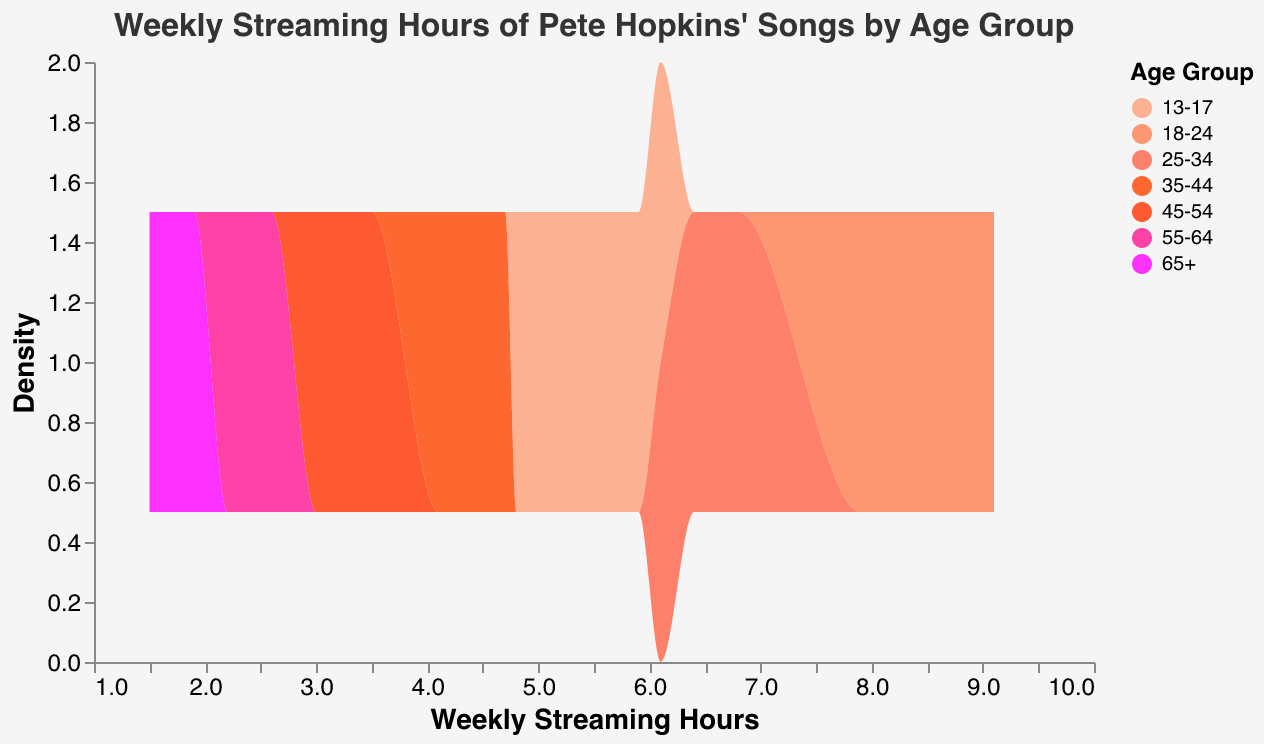What's the title of the density plot? The title of the plot is located at the top. It reads "Weekly Streaming Hours of Pete Hopkins' Songs by Age Group".
Answer: Weekly Streaming Hours of Pete Hopkins' Songs by Age Group What are the age groups displayed in the legend? The age groups are shown in the color legend on the right side of the plot. They include 13-17, 18-24, 25-34, 35-44, 45-54, 55-64, and 65+.
Answer: 13-17, 18-24, 25-34, 35-44, 45-54, 55-64, 65+ Which age group has the highest density peak? The density peak is the highest point on the density curve, indicating the highest concentration of data points. The age group 18-24 shows the highest peak, suggesting they stream Pete Hopkins' songs the most weekly.
Answer: 18-24 What is the range of weekly streaming hours for the 25-34 age group? The weekly streaming hours for the 25-34 age group range from 6.1 to 6.8 hours, as shown by the spread of their density plot.
Answer: 6.1 to 6.8 hours How does the density of the 55-64 age group compare to the 65+ age group? By observing the plot, the density outlines for the 55-64 and 65+ age groups can be compared. The 55-64 group has a higher density indicating more concentration around 2.2-2.6 hours, while the 65+ group has its density spread around 1.5-1.9 hours but is comparatively lower.
Answer: 55-64 has a higher density than 65+ Which age group has the lowest weekly streaming hours? The 65+ age group has the lowest weekly streaming hours, with values ranging from 1.5 to 1.9 hours, which is visible at the left-most part of the plot for this group's density.
Answer: 65+ What is the average weekly streaming hour for the 18-24 age group? To calculate the average: add all the weekly streaming hours of the 18-24 group (8.3 + 7.9 + 8.7 + 9.1 + 8.5 = 42.5) and divide by the number of data points (5). So, 42.5 / 5 = 8.5 hours.
Answer: 8.5 hours What is the major mode of weekly streaming hours for the 35-44 age group? The major mode is the value with the highest frequency in the density plot for the 35-44 age group, which peaks around 4.5 weekly streaming hours.
Answer: 4.5 hours How does the density peak of the 13-17 age group compare to that of the 45-54 age group? The density peak of the 13-17 age group is higher than that of the 45-54 age group. This suggests that younger users (13-17) stream more weekly hours compared to the 45-54 age group.
Answer: 13-17 has a higher peak than 45-54 